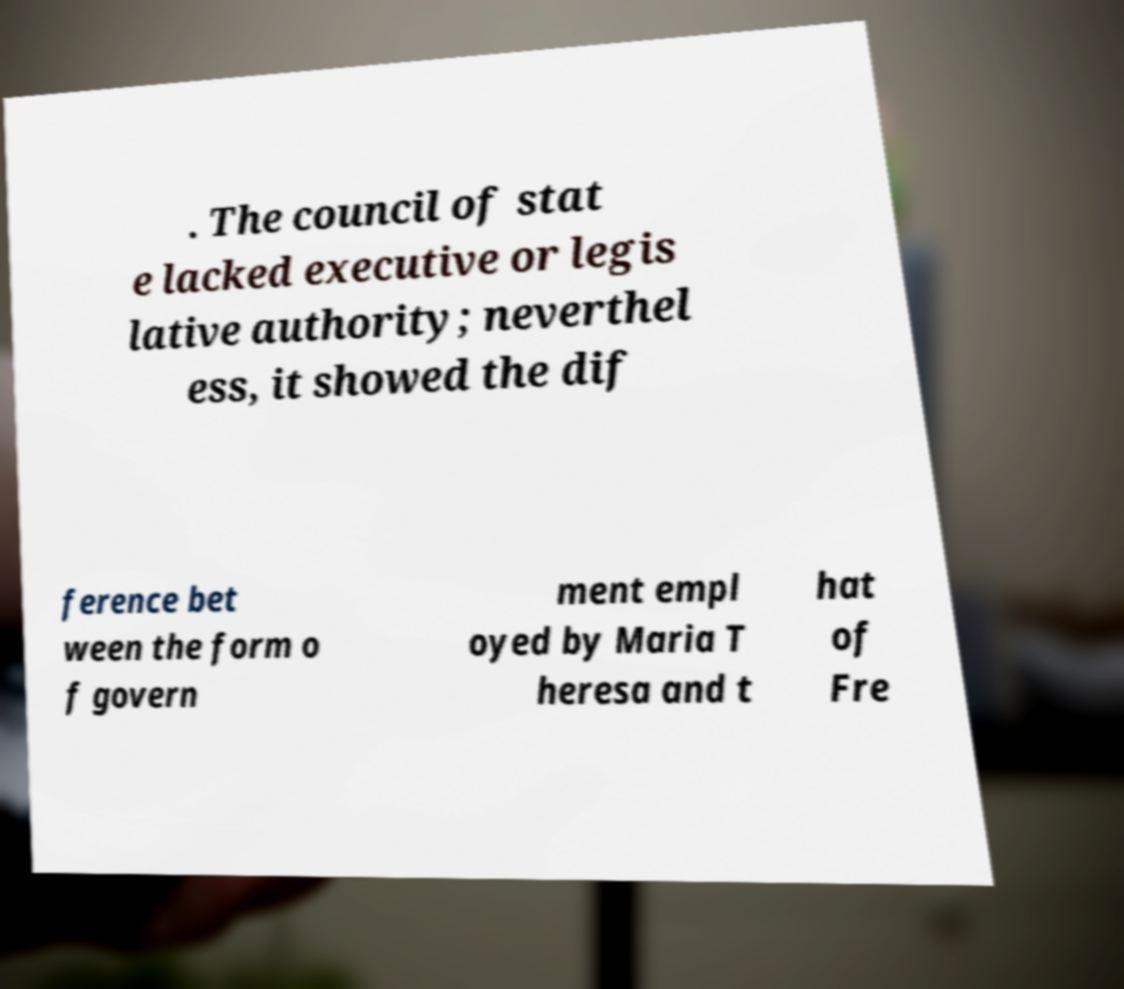Please read and relay the text visible in this image. What does it say? . The council of stat e lacked executive or legis lative authority; neverthel ess, it showed the dif ference bet ween the form o f govern ment empl oyed by Maria T heresa and t hat of Fre 